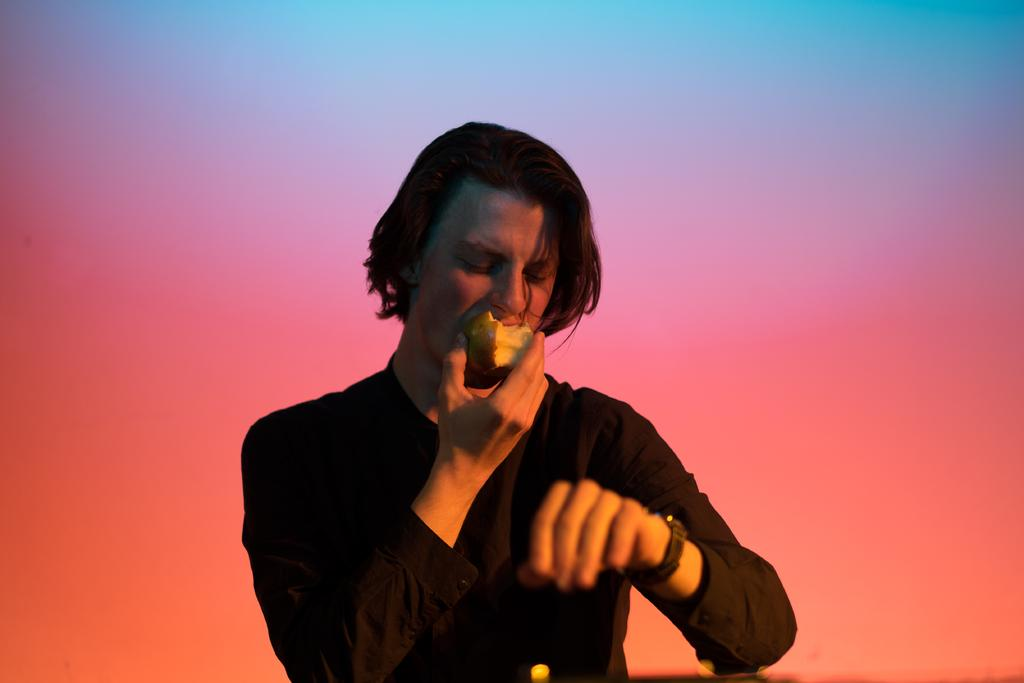What is the main subject of the image? There is a person in the image. What is the person holding in the image? The person is holding an apple. What type of machine is visible in the image? There is no machine present in the image; it features a person holding an apple. How many clocks can be seen in the image? There are no clocks visible in the image. 